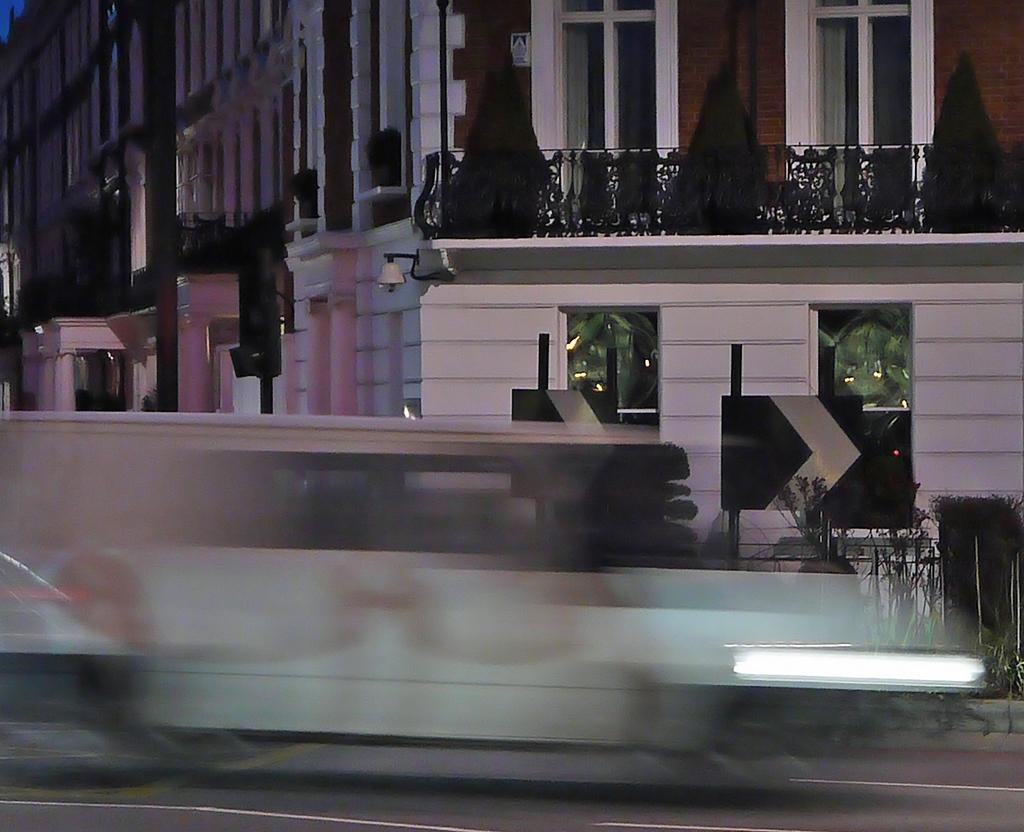What is the condition of the front part of the image? The front of the image is blurred. What can be seen behind the blurred part? There are sign boards behind the blurred part. What is present on the pavement in the image? There are plants on the pavement. What can be seen in the background of the image? There are traffic lights and buildings in the background. How many books are stacked on the hook in the image? There are no books or hooks present in the image. 